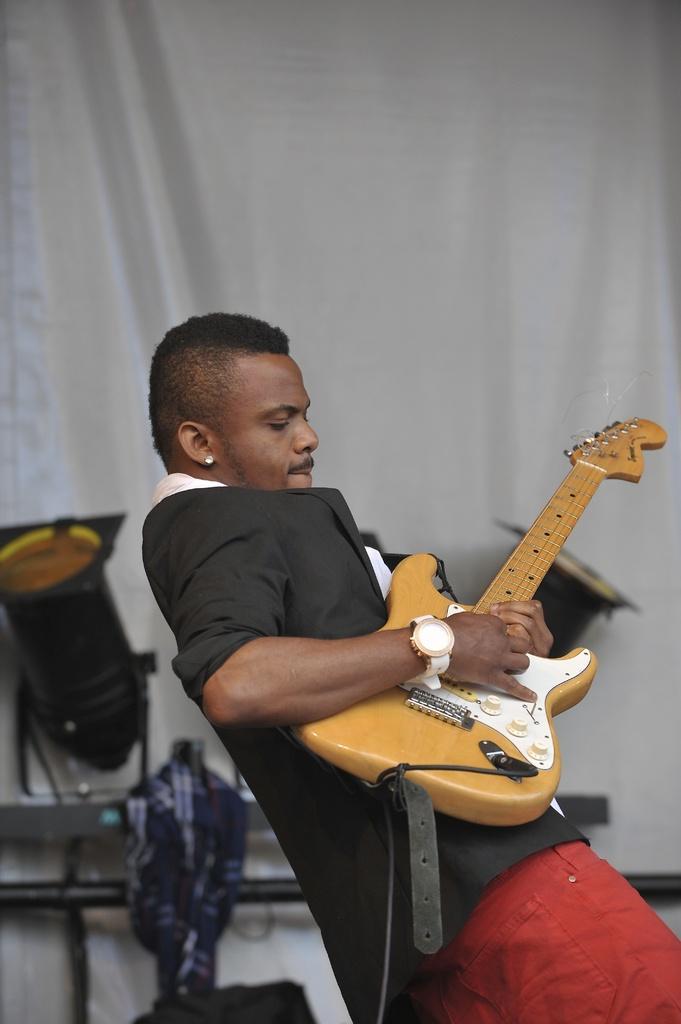Please provide a concise description of this image. In a picture one person is playing a guitar, he is wearing red pants and black coat behind him there is a curtain and one cloth piece and focus lights are present. 